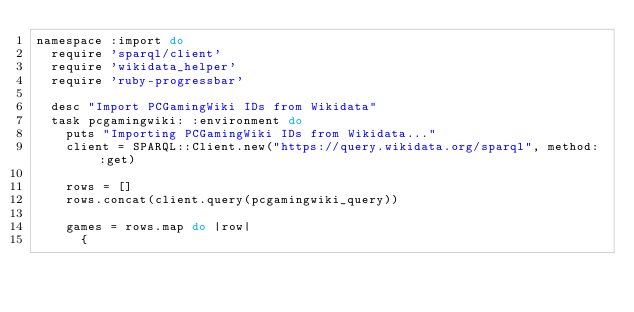<code> <loc_0><loc_0><loc_500><loc_500><_Ruby_>namespace :import do
  require 'sparql/client'
  require 'wikidata_helper'
  require 'ruby-progressbar'

  desc "Import PCGamingWiki IDs from Wikidata"
  task pcgamingwiki: :environment do
    puts "Importing PCGamingWiki IDs from Wikidata..."
    client = SPARQL::Client.new("https://query.wikidata.org/sparql", method: :get)

    rows = []
    rows.concat(client.query(pcgamingwiki_query))

    games = rows.map do |row|
      {</code> 